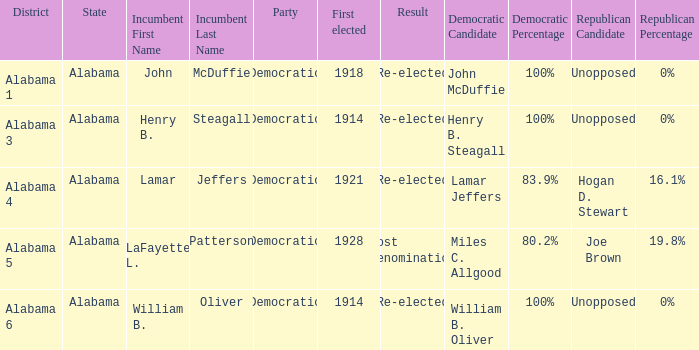How many in lost renomination results were elected first? 1928.0. 